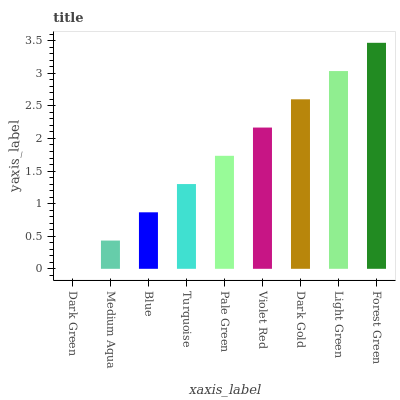Is Dark Green the minimum?
Answer yes or no. Yes. Is Forest Green the maximum?
Answer yes or no. Yes. Is Medium Aqua the minimum?
Answer yes or no. No. Is Medium Aqua the maximum?
Answer yes or no. No. Is Medium Aqua greater than Dark Green?
Answer yes or no. Yes. Is Dark Green less than Medium Aqua?
Answer yes or no. Yes. Is Dark Green greater than Medium Aqua?
Answer yes or no. No. Is Medium Aqua less than Dark Green?
Answer yes or no. No. Is Pale Green the high median?
Answer yes or no. Yes. Is Pale Green the low median?
Answer yes or no. Yes. Is Light Green the high median?
Answer yes or no. No. Is Blue the low median?
Answer yes or no. No. 